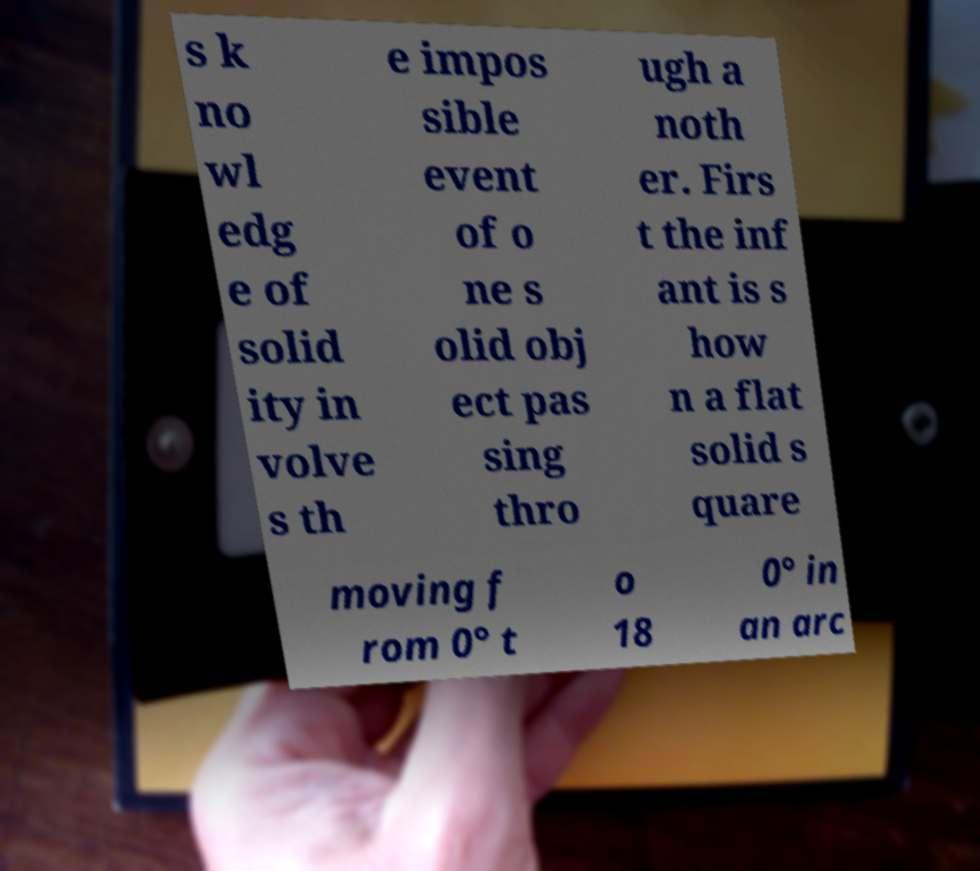What messages or text are displayed in this image? I need them in a readable, typed format. s k no wl edg e of solid ity in volve s th e impos sible event of o ne s olid obj ect pas sing thro ugh a noth er. Firs t the inf ant is s how n a flat solid s quare moving f rom 0° t o 18 0° in an arc 